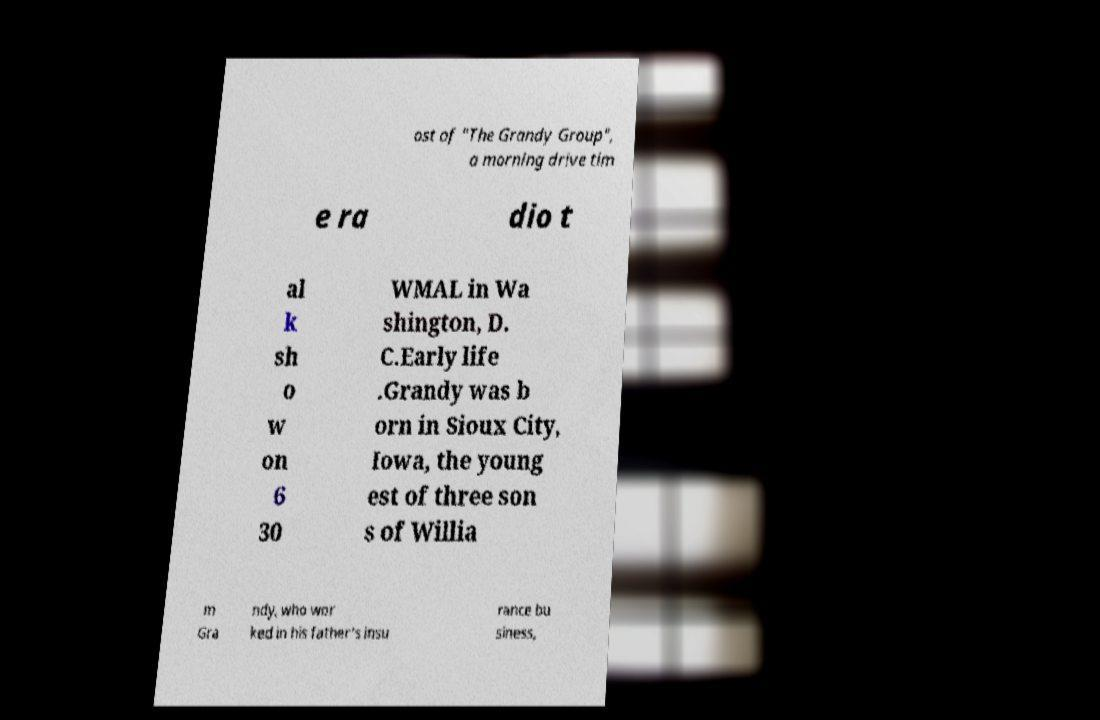What messages or text are displayed in this image? I need them in a readable, typed format. ost of "The Grandy Group", a morning drive tim e ra dio t al k sh o w on 6 30 WMAL in Wa shington, D. C.Early life .Grandy was b orn in Sioux City, Iowa, the young est of three son s of Willia m Gra ndy, who wor ked in his father's insu rance bu siness, 